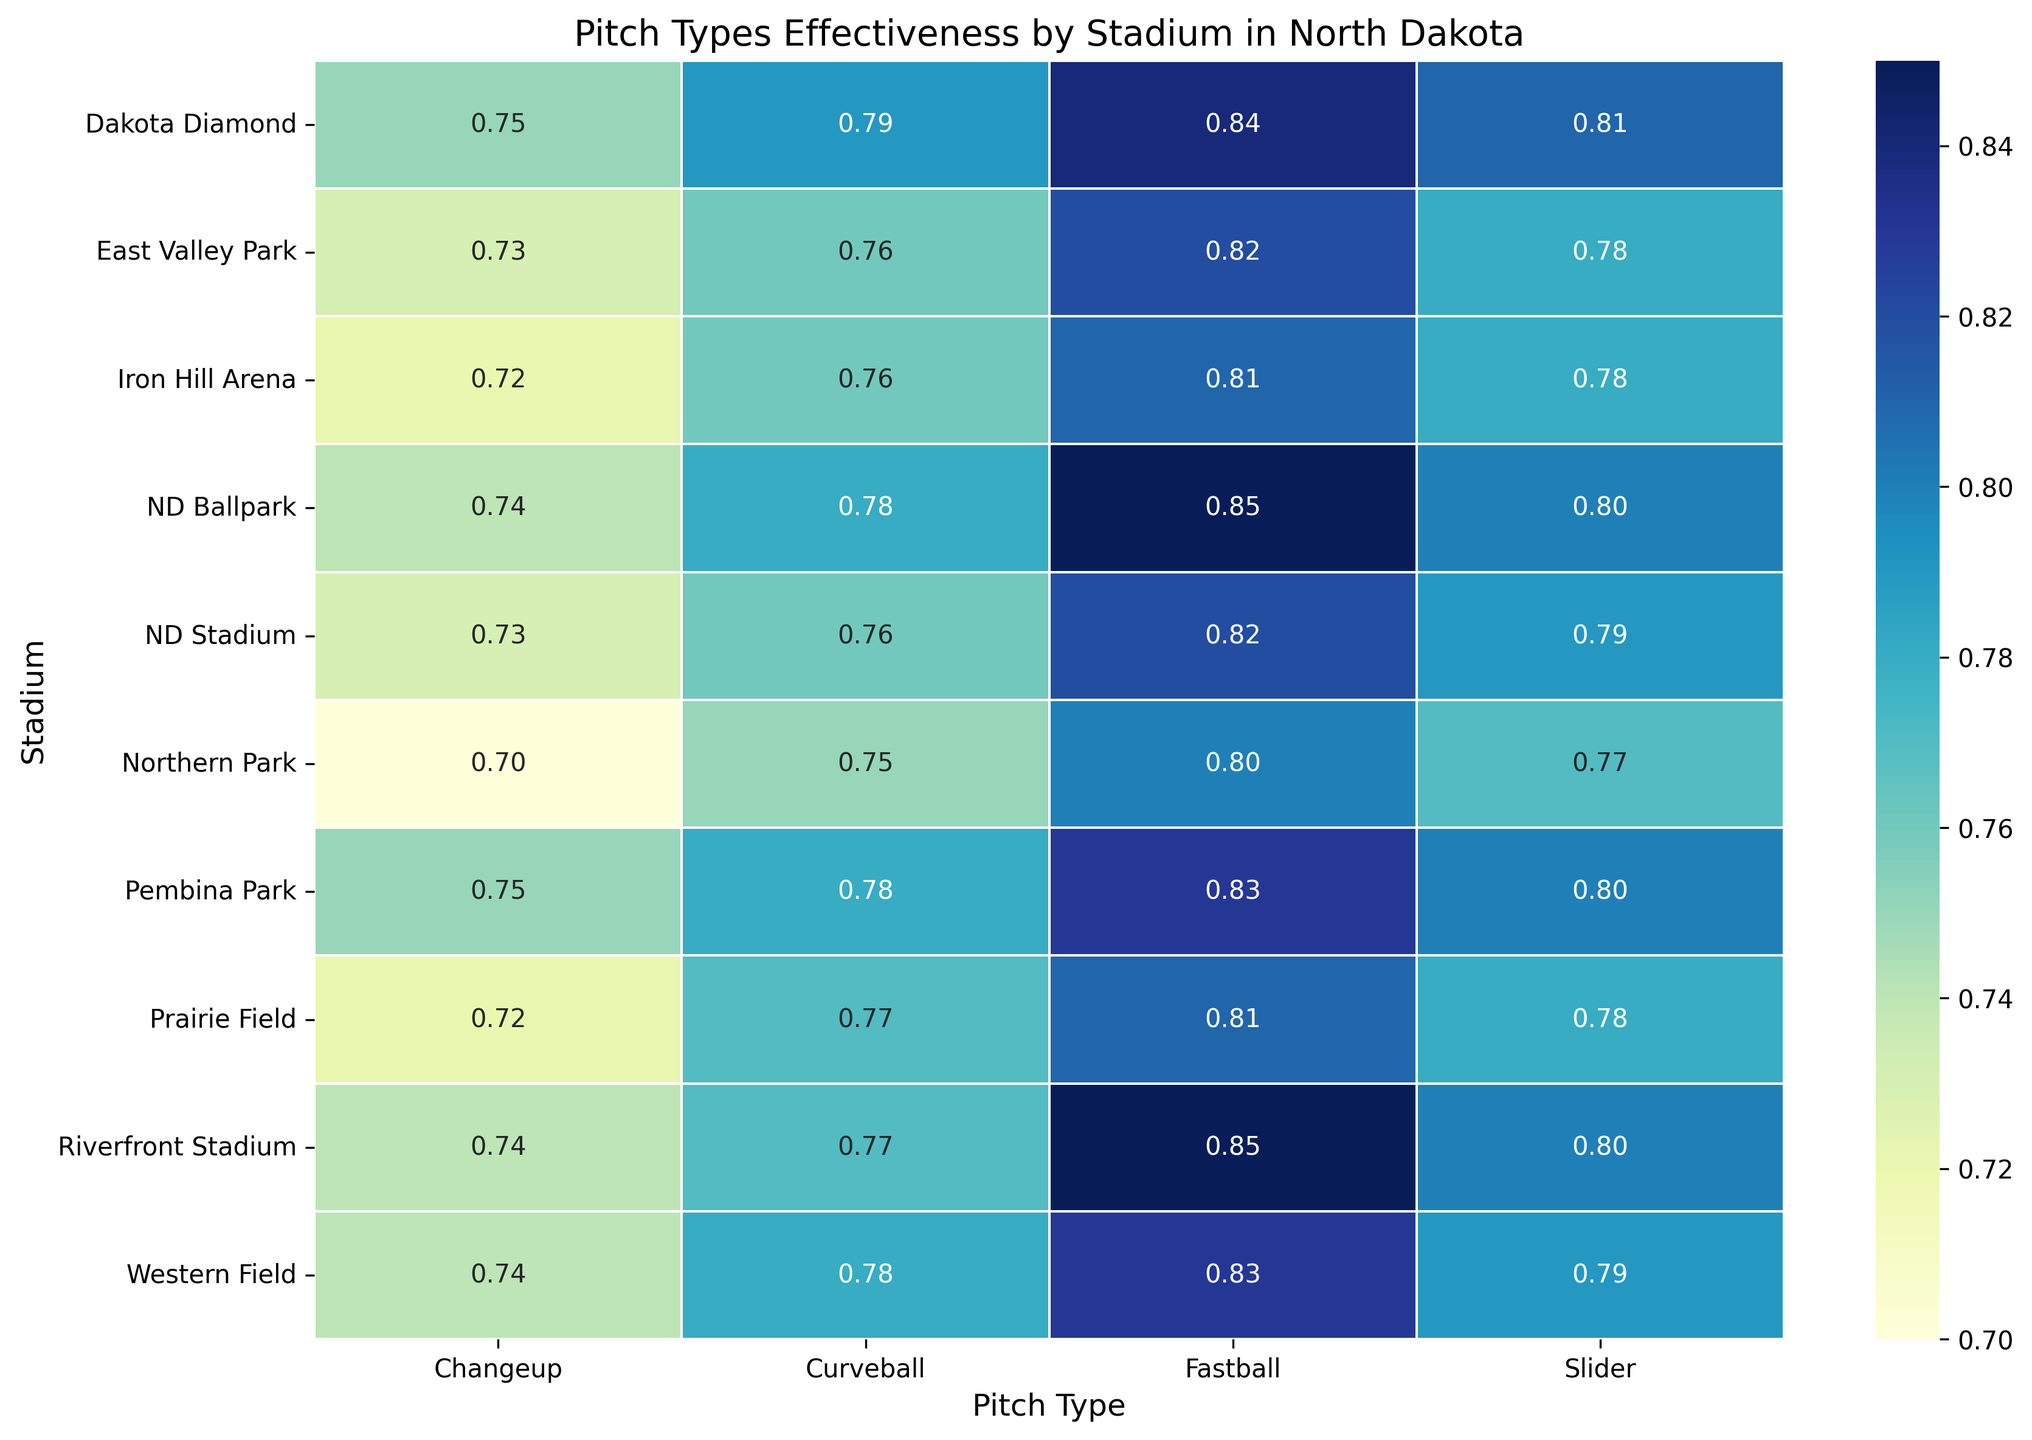Which stadium shows the highest effectiveness for Fastballs? Compare the Fastball effectiveness values for all the stadiums and find the highest value. The highest value is 0.85, which is recorded for ND Ballpark and Riverfront Stadium.
Answer: ND Ballpark and Riverfront Stadium How does the effectiveness of Curveballs in Northern Park compare to Dakota Diamond? Look at the effectiveness values of Curveballs for Northern Park (0.75) and Dakota Diamond (0.79). Northern Park's value is lower.
Answer: Northern Park is less effective What's the average effectiveness of Changeups across all stadiums? Add the effectiveness values of Changeups across all stadiums and divide by the number of stadiums: (0.74 + 0.73 + 0.72 + 0.75 + 0.70 + 0.74 + 0.73 + 0.74 + 0.72 + 0.75) / 10. The sum is 7.32, and the number of stadiums is 10. 7.32/10 = 0.732.
Answer: 0.732 Which pitch type shows the most consistent effectiveness across all stadiums? Compare the range (difference between maximum and minimum values) for each pitch type: Fastball (range = 0.85 - 0.80 = 0.05), Curveball (0.79 - 0.75 = 0.04), Slider (0.81 - 0.77 = 0.04), Changeup (0.75 - 0.70 = 0.05). Effectiveness of Curveballs and Sliders is more consistent, both with a range of 0.04.
Answer: Curveballs and Sliders What is the effectiveness range of Fastballs across these stadiums? Calculate the difference between the maximum and minimum effectiveness values of Fastballs: 0.85 (max) - 0.80 (min) = 0.05.
Answer: 0.05 Which stadium has the least effective Changeup? Compare the Changeup effectiveness values across all stadiums and identify the minimum value. The smallest value is 0.70 at Northern Park.
Answer: Northern Park Is the effectiveness of Sliders in Western Field greater than in Prairie Field? Compare the effectiveness values of Sliders in Western Field (0.79) and Prairie Field (0.78). Western Field has a higher value.
Answer: Yes How does the average effectiveness of all pitch types in ND Stadium compare to Pembina Park? Calculate the average effectiveness for all pitch types in ND Stadium: (0.82 + 0.76 + 0.79 + 0.73) / 4 = 3.10/4 = 0.775. For Pembina Park: (0.83 + 0.78 + 0.80 + 0.75) / 4 = 3.16/4 = 0.79. Pembina Park has a higher average.
Answer: Pembina Park is higher Which combination of stadium and pitch type has the lowest effectiveness? Identify the lowest value in the heatmap. The smallest effectiveness value is 0.70, recorded for Changeup at Northern Park.
Answer: Northern Park - Changeup What’s the average effectiveness of Fastballs and Sliders in Riverfront Stadium? Add the effectiveness values of Fastballs (0.85) and Sliders (0.80) in Riverfront Stadium, then divide by 2: (0.85 + 0.80) / 2 = 1.65 / 2 = 0.825.
Answer: 0.825 